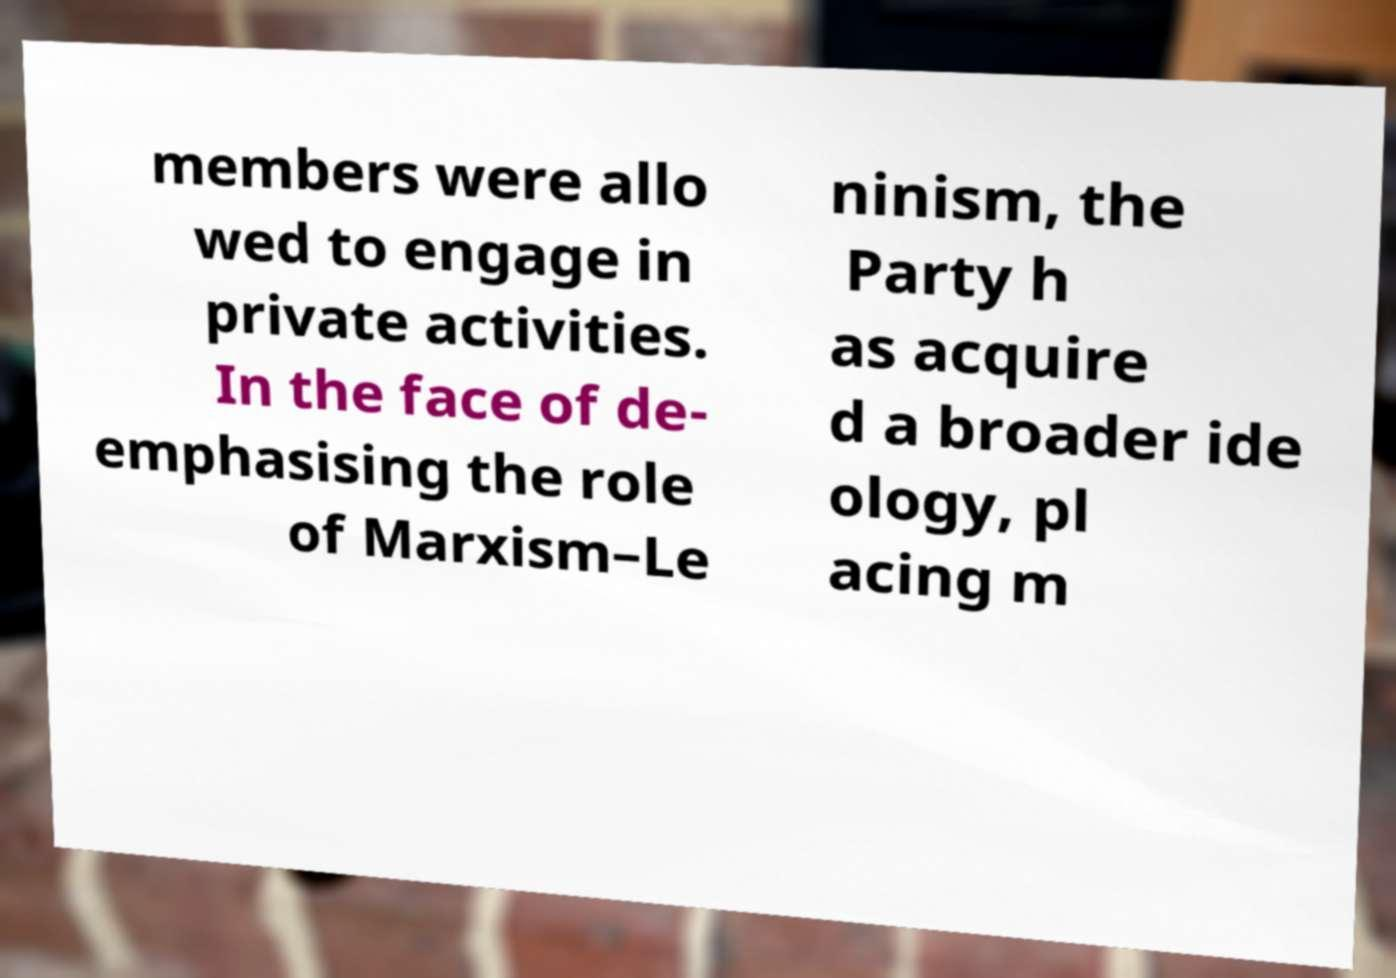Could you extract and type out the text from this image? members were allo wed to engage in private activities. In the face of de- emphasising the role of Marxism–Le ninism, the Party h as acquire d a broader ide ology, pl acing m 